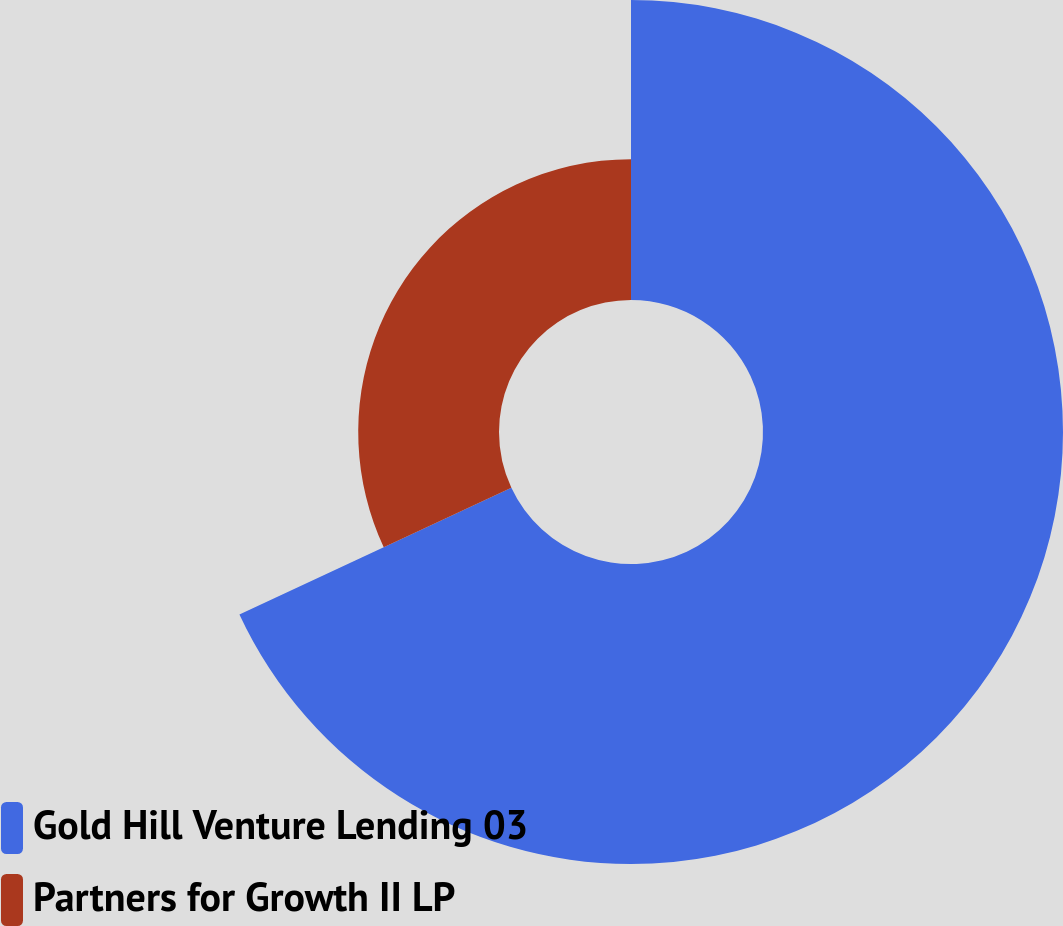Convert chart. <chart><loc_0><loc_0><loc_500><loc_500><pie_chart><fcel>Gold Hill Venture Lending 03<fcel>Partners for Growth II LP<nl><fcel>68.06%<fcel>31.94%<nl></chart> 